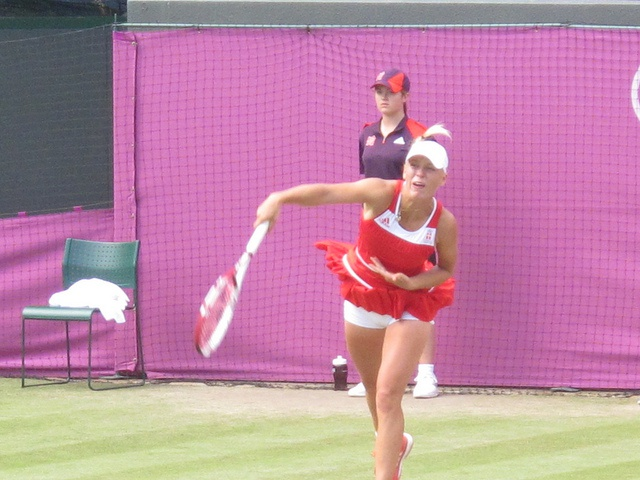Describe the objects in this image and their specific colors. I can see people in purple, salmon, lightgray, and brown tones, chair in purple, white, violet, gray, and darkgray tones, people in purple, violet, white, and lightpink tones, tennis racket in purple, lavender, lightpink, pink, and violet tones, and bottle in purple, brown, and white tones in this image. 